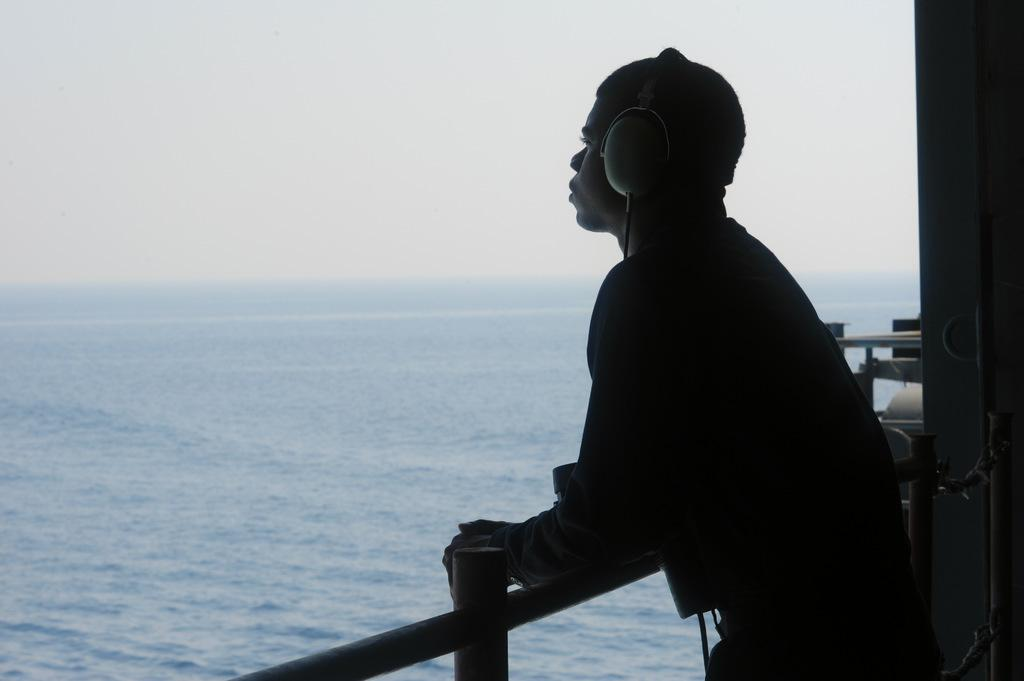Who is present in the image? There is a man in the image. What is the man wearing on his head? The man is wearing headsets. Where is the man standing in relation to the railing? The man is standing near a railing. What can be seen on the right side of the image? There is a wall on the right side of the image. What is visible in the background of the image? Water and the sky are visible in the background of the image. What type of can is visible in the image? There is no can present in the image. What genre of music is the man listening to in the image? The image does not provide any information about the music the man might be listening to. 